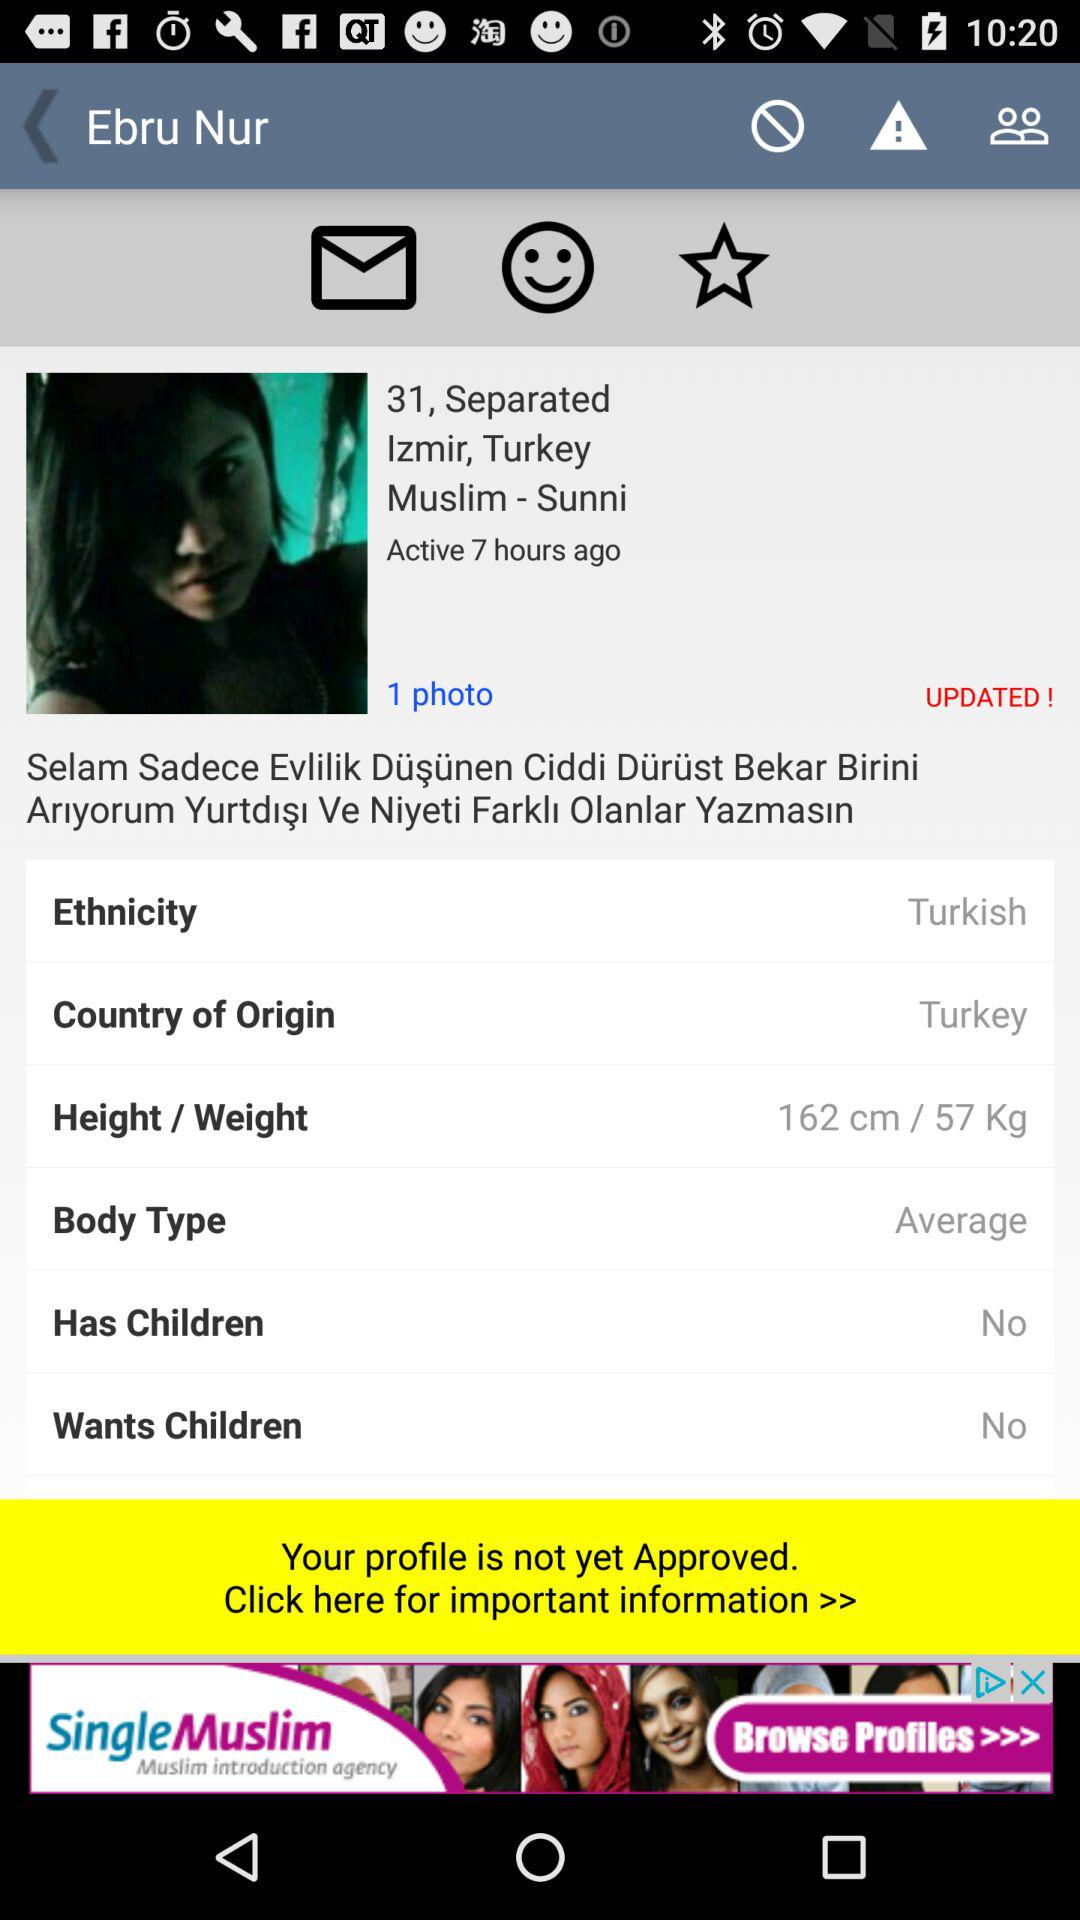How many children does this individual desire? This individual does not want children. 